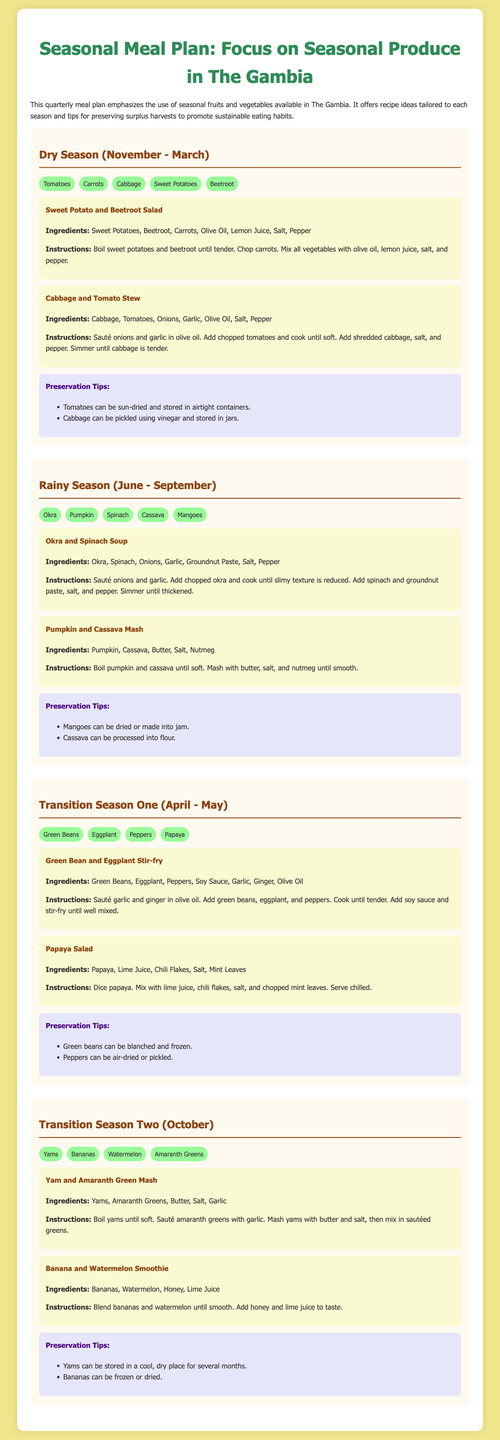what is the duration of the dry season? The document states that the dry season lasts from November to March, which is a total of 5 months.
Answer: November - March which fruit is mentioned in the transition season two? The document lists bananas, watermelon, and yams as produce available in the transition season two.
Answer: Bananas what is one ingredient in the Okra and Spinach Soup? According to the recipe, the Okra and Spinach Soup contains okra as one of its ingredients.
Answer: Okra how many recipes are provided for the rainy season? The document shows two recipes specifically tailored for the rainy season.
Answer: 2 what are preservation tips suggested for cabbage? Preservation tips mention that cabbage can be pickled using vinegar and stored in jars.
Answer: Pickled using vinegar what is the main vegetable used in the Sweet Potato and Beetroot Salad? The salad includes sweet potatoes as the main vegetable among other ingredients.
Answer: Sweet Potatoes name a fruit that can be dried according to the preservation tips. The preservation tips indicate that mangoes can be dried.
Answer: Mangoes which vegetable is used in both the Dry Season and Transition Season One? The document lists carrots being used in the Dry Season's recipes and also mentions it indirectly through the Sweet Potato and Beetroot Salad.
Answer: Carrots how is the Pumpkin and Cassava Mash prepared? The recipe states that pumpkin and cassava should be boiled until soft and then mashed with butter, salt, and nutmeg.
Answer: Boiled and mashed 